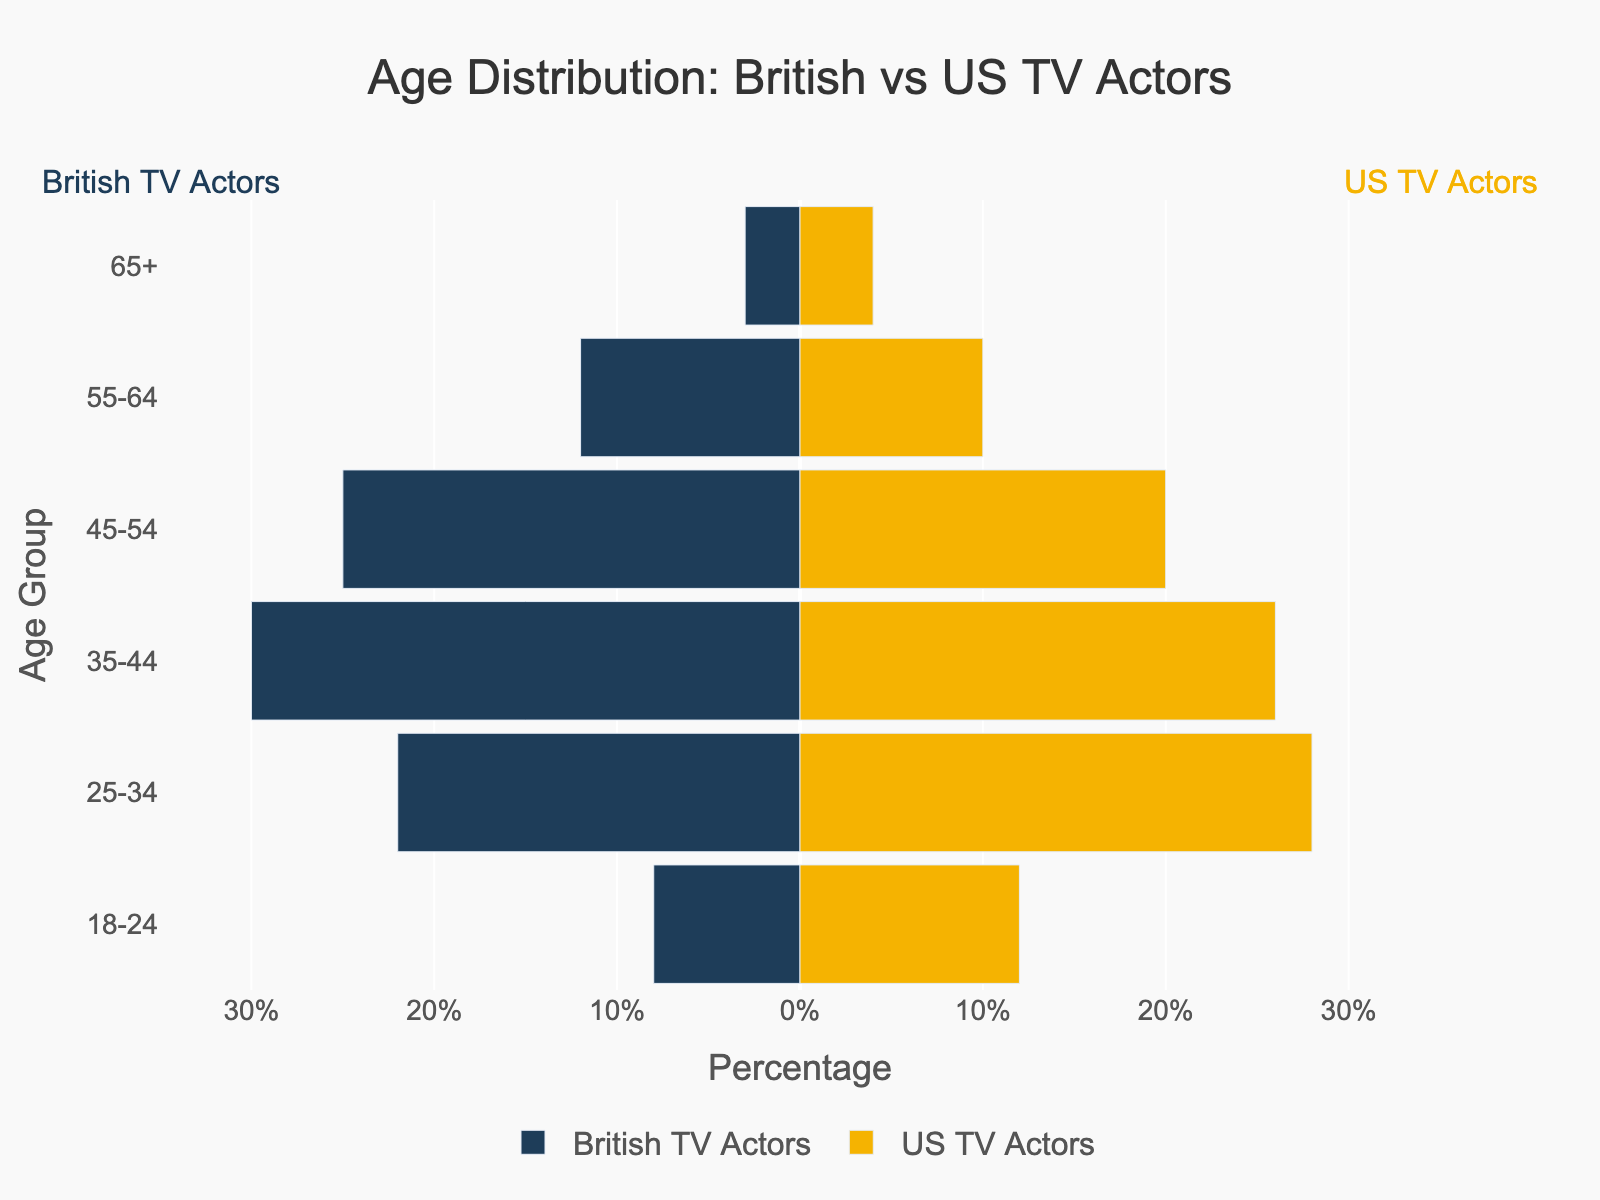What is the title of the figure? The title is typically located at the top of the plot. Here, it reads "Age Distribution: British vs US TV Actors".
Answer: Age Distribution: British vs US TV Actors What age group in British TV shows has the highest percentage of actors? Look at the British TV Actors bars and identify which age group has the longest bar. For British actors, the age group 35-44 has the highest percentage at 30%.
Answer: 35-44 Which age group has a higher percentage of US TV actors compared to British TV actors? Compare the lengths of the bars for each age group. The age groups 18-24, 25-34, and 65+ have higher percentages of US TV actors compared to British TV actors.
Answer: 18-24, 25-34, 65+ In which age group is the percentage difference between British and US TV actors the greatest? Calculate the absolute difference between the percentages of British and US TV actors for each age group. The largest difference occurs in the 25-34 age group with a difference of (28% - 22% = 6%).
Answer: 25-34 What is the total percentage of British TV actors aged 35-54? Sum the percentages for the age groups 35-44 and 45-54 for British TV actors. The sum is 30% + 25% = 55%.
Answer: 55% For which age groups are the percentages of British TV actors lower than those of US TV actors? Compare the percentages for each age group and identify where British actors have lower values. These groups are 18-24, 25-34, and 65+.
Answer: 18-24, 25-34, 65+ Which age group has the smallest difference in the percentage of actors between British and US TV shows? Compute the absolute differences for each age group and find the smallest one. The smallest difference is for the age group 35-44, where the percentage is 30% for British and 26% for US actors, making a difference of 4%.
Answer: 35-44 How many age groups have a higher percentage of British TV actors compared to US TV actors? Count the number of age groups where the British bar is longer than the US bar. The age groups 35-44, 45-54, and 55-64 have higher percentages for British actors. There are 3 such age groups.
Answer: 3 What is the combined percentage of actors aged 55 and above for both British and US TV shows? Sum the percentages of the age groups 55-64 and 65+ for both British and US TV actors. For British actors, it's 12% + 3% = 15%. For US actors, it's 10% + 4% = 14%. The combined percentage is 15% + 14% = 29%.
Answer: 29% Which age group shows the closest percentage between British and US TV actors? Find the age group with the smallest absolute difference between the two. The closest percentages are in the age group 65+, with British at 3% and US at 4%, making a difference of 1%.
Answer: 65+ 